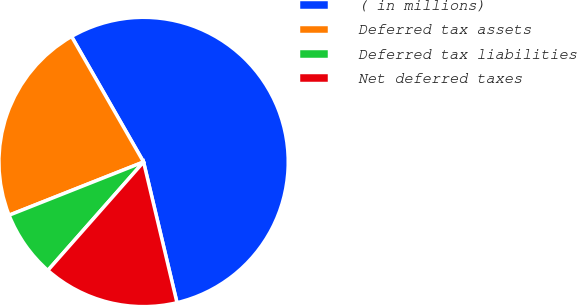Convert chart. <chart><loc_0><loc_0><loc_500><loc_500><pie_chart><fcel>( in millions)<fcel>Deferred tax assets<fcel>Deferred tax liabilities<fcel>Net deferred taxes<nl><fcel>54.58%<fcel>22.71%<fcel>7.49%<fcel>15.22%<nl></chart> 